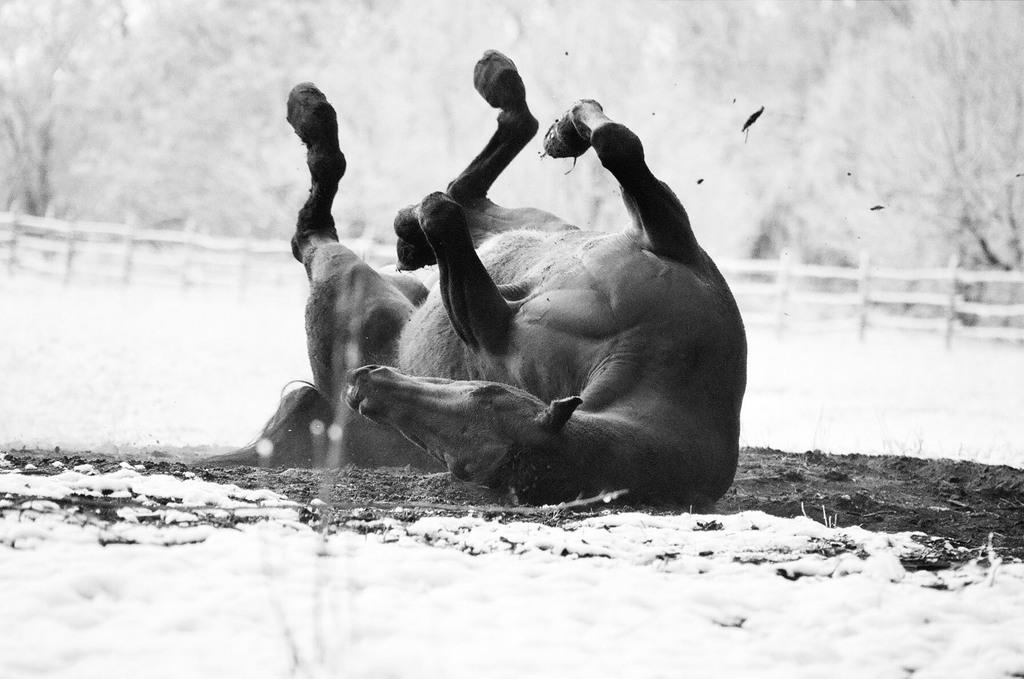What type of animal can be seen in the image? There is an animal in the image, but the specific type cannot be determined from the facts provided. What is the animal doing in the image? The animal is lying down on the ground. What is the environment like in the image? There is snow visible in the image. What type of magic is being performed by the animal in the image? There is no indication of magic or any magical activity in the image. The animal is simply lying down on the ground in a snowy environment. 